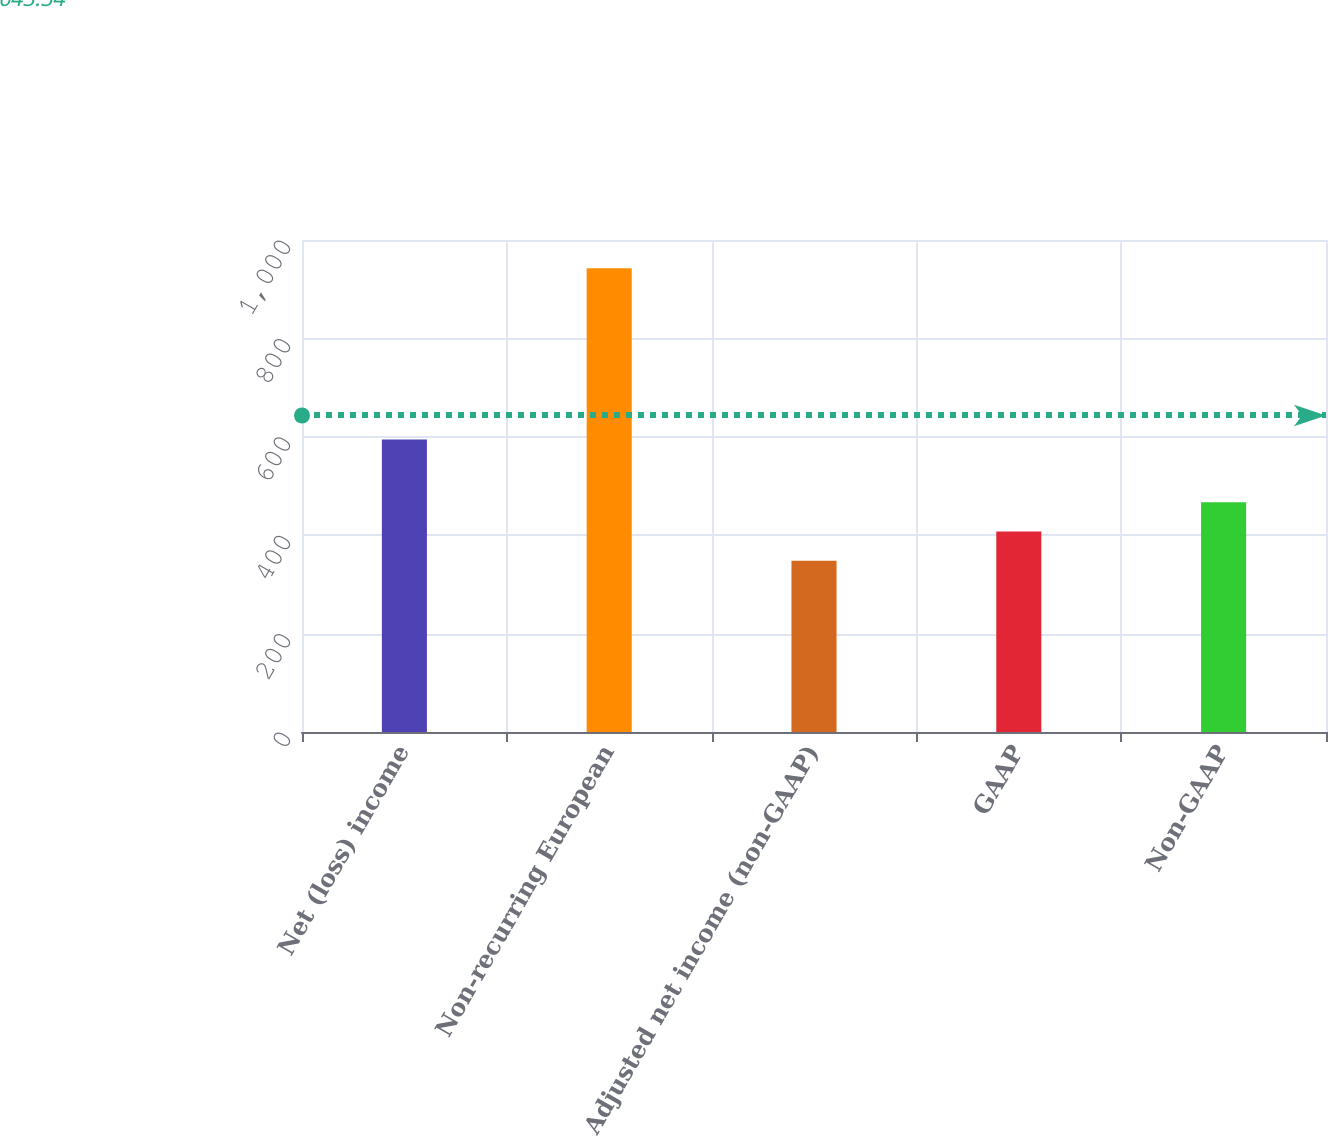Convert chart to OTSL. <chart><loc_0><loc_0><loc_500><loc_500><bar_chart><fcel>Net (loss) income<fcel>Non-recurring European<fcel>Adjusted net income (non-GAAP)<fcel>GAAP<fcel>Non-GAAP<nl><fcel>594.6<fcel>942.6<fcel>348<fcel>407.46<fcel>466.92<nl></chart> 